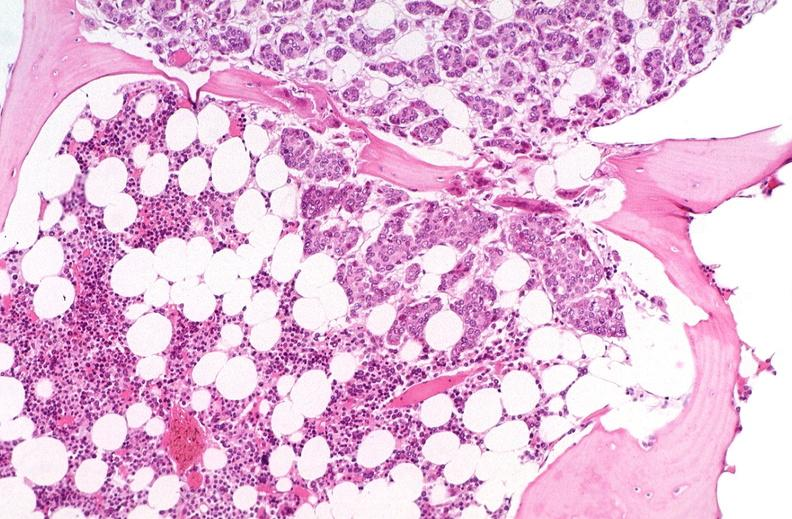s hematologic present?
Answer the question using a single word or phrase. Yes 